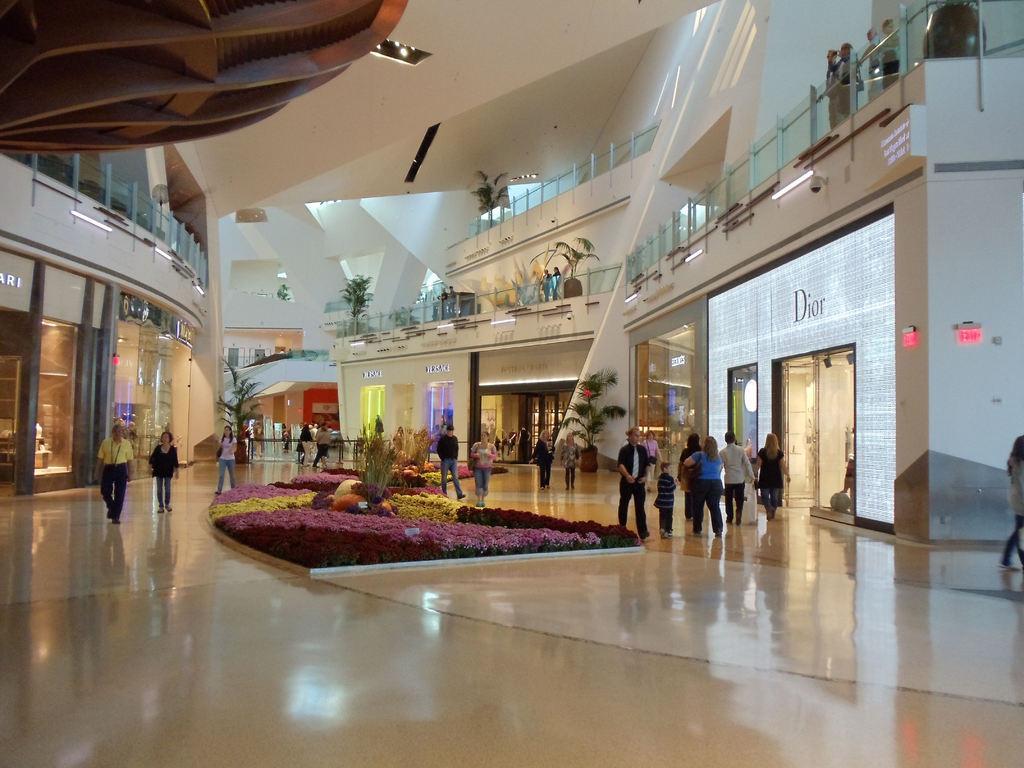How would you summarize this image in a sentence or two? This picture might be taken in a mall, in this image there are some persons walking and on the right side and left side there are some stores and glass doors. On the doors there is some text, and at the top there is a railing and some plants and also there are some lights and wall. In the center there are some plants, at the bottom there is floor. 